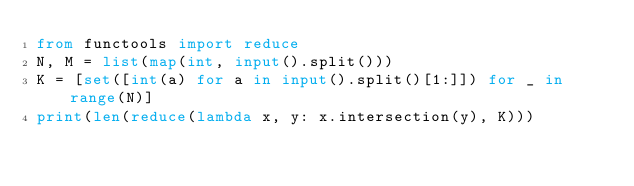Convert code to text. <code><loc_0><loc_0><loc_500><loc_500><_Python_>from functools import reduce
N, M = list(map(int, input().split()))
K = [set([int(a) for a in input().split()[1:]]) for _ in range(N)]
print(len(reduce(lambda x, y: x.intersection(y), K)))

</code> 